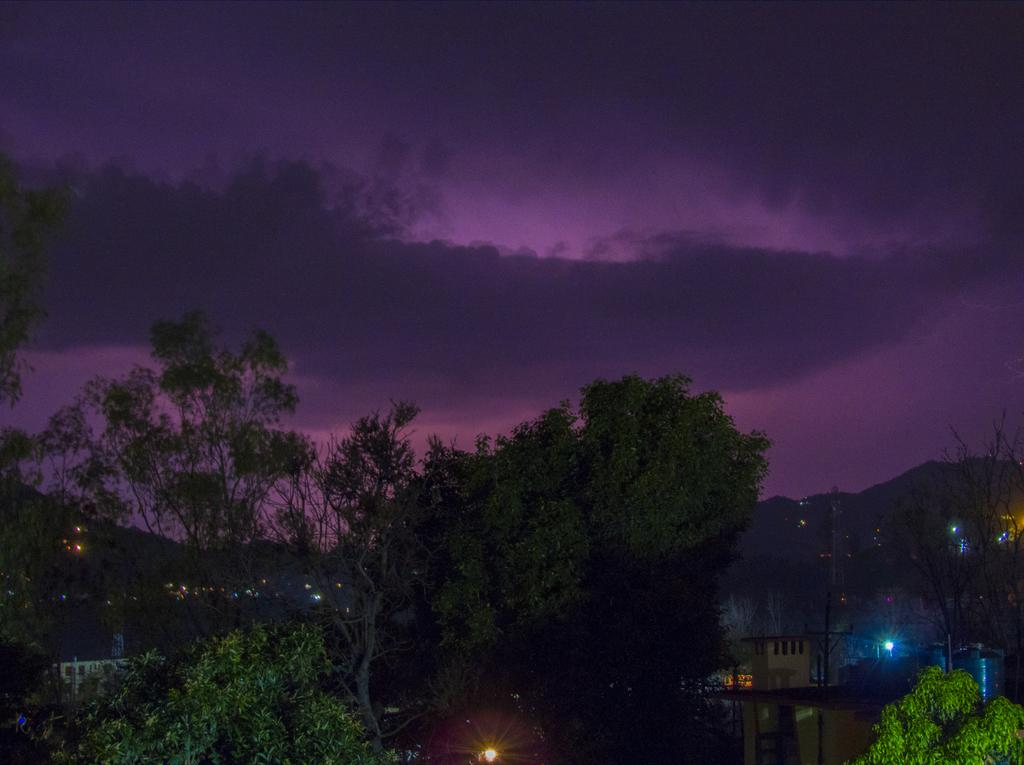What type of vegetation can be seen in the image? There are trees in the image. What else is visible in the image besides the trees? There are lights and a house in the image. What is visible at the top of the image? The sky is visible at the top of the image. What type of gold furniture can be seen in the image? There is no gold furniture present in the image. The image features trees, lights, and a house, but no furniture is mentioned or visible. 